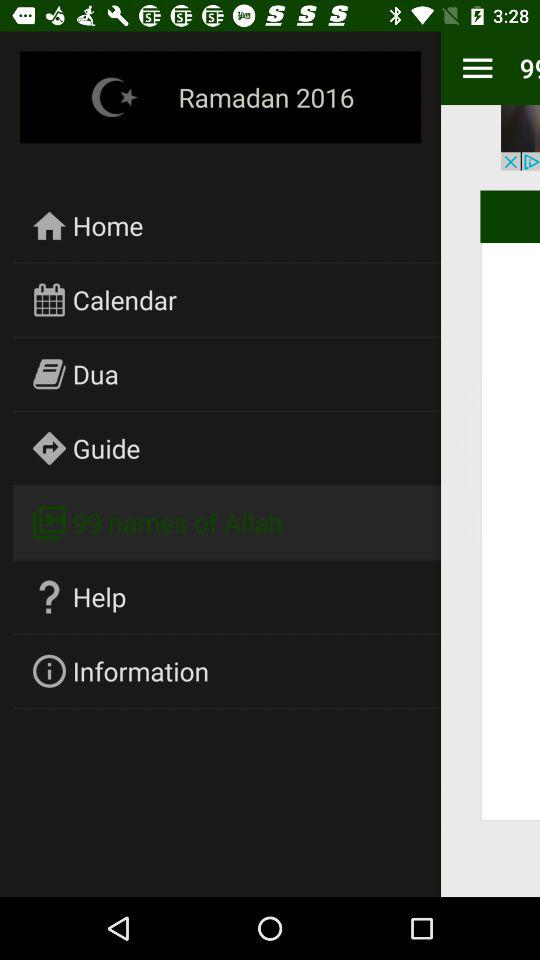How many names of Allah are there? There are 99 names of Allah. 